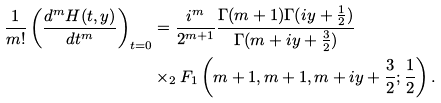Convert formula to latex. <formula><loc_0><loc_0><loc_500><loc_500>\frac { 1 } { m ! } \left ( \frac { d ^ { m } H ( t , y ) } { d t ^ { m } } \right ) _ { t = 0 } & = \frac { i ^ { m } } { 2 ^ { m + 1 } } \frac { \Gamma ( m + 1 ) \Gamma ( i y + \frac { 1 } { 2 } ) } { \Gamma ( m + i y + \frac { 3 } { 2 } ) } \\ & \times _ { 2 } F _ { 1 } \left ( m + 1 , m + 1 , m + i y + \frac { 3 } { 2 } ; \frac { 1 } { 2 } \right ) .</formula> 